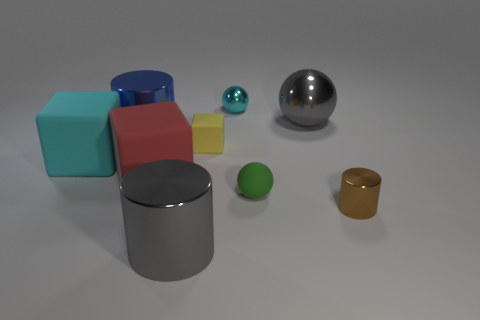Subtract all gray cylinders. How many cylinders are left? 2 Add 1 tiny matte cubes. How many objects exist? 10 Subtract 1 cylinders. How many cylinders are left? 2 Subtract all balls. How many objects are left? 6 Subtract all green cylinders. Subtract all green cubes. How many cylinders are left? 3 Add 8 gray shiny balls. How many gray shiny balls exist? 9 Subtract 1 brown cylinders. How many objects are left? 8 Subtract all red rubber things. Subtract all tiny green matte balls. How many objects are left? 7 Add 5 spheres. How many spheres are left? 8 